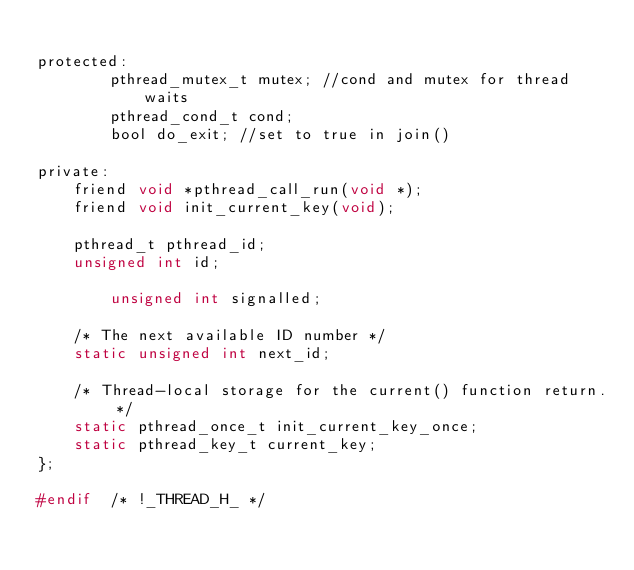Convert code to text. <code><loc_0><loc_0><loc_500><loc_500><_C_>
protected:
        pthread_mutex_t mutex; //cond and mutex for thread waits
        pthread_cond_t cond;
        bool do_exit; //set to true in join()

private:
	friend void *pthread_call_run(void *);
	friend void init_current_key(void);

	pthread_t pthread_id;
	unsigned int id;

        unsigned int signalled;

	/* The next available ID number */
	static unsigned int next_id;

	/* Thread-local storage for the current() function return. */
	static pthread_once_t init_current_key_once;
	static pthread_key_t current_key;
};

#endif	/* !_THREAD_H_ */
</code> 